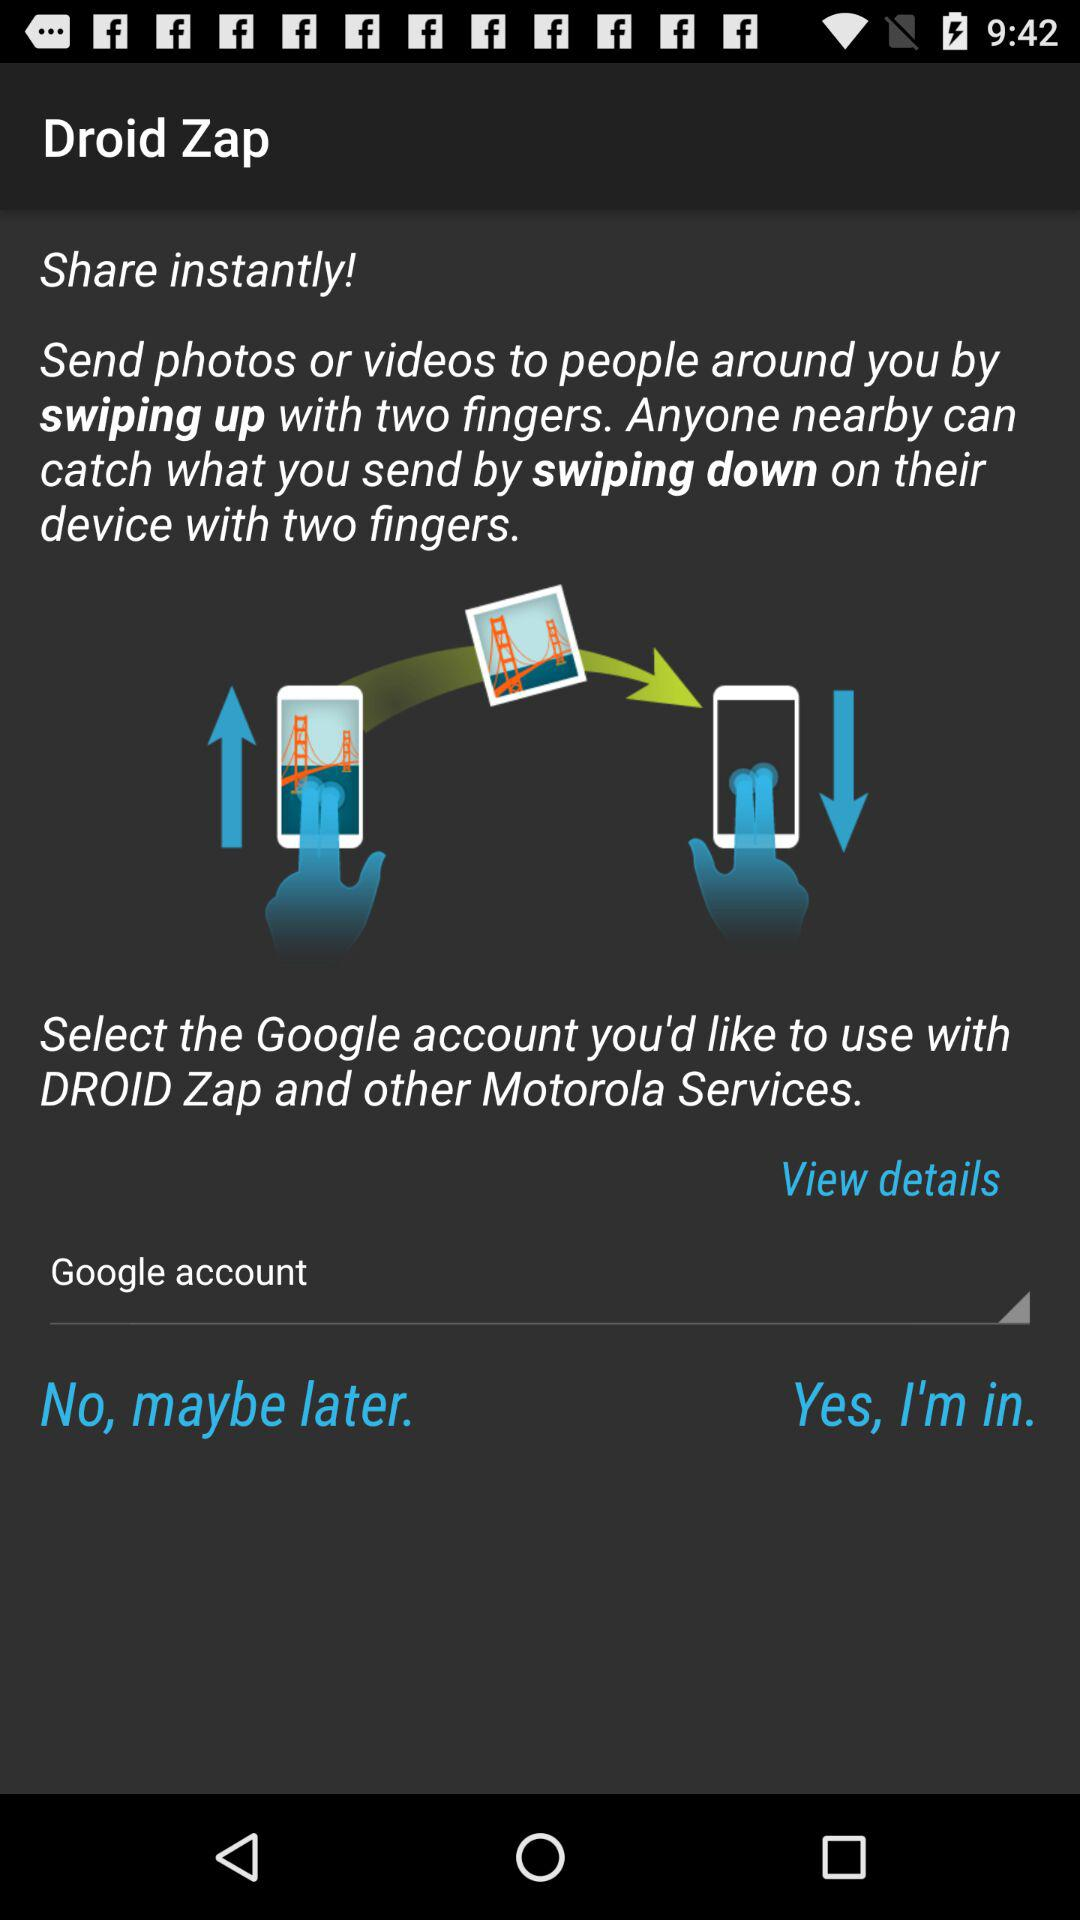What is the name of application? The name of the application is "Droid Zap". 